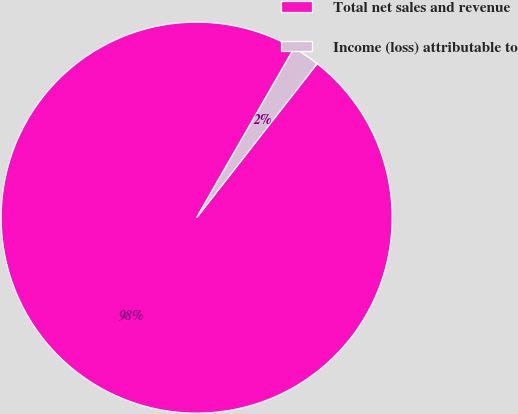<chart> <loc_0><loc_0><loc_500><loc_500><pie_chart><fcel>Total net sales and revenue<fcel>Income (loss) attributable to<nl><fcel>97.74%<fcel>2.26%<nl></chart> 